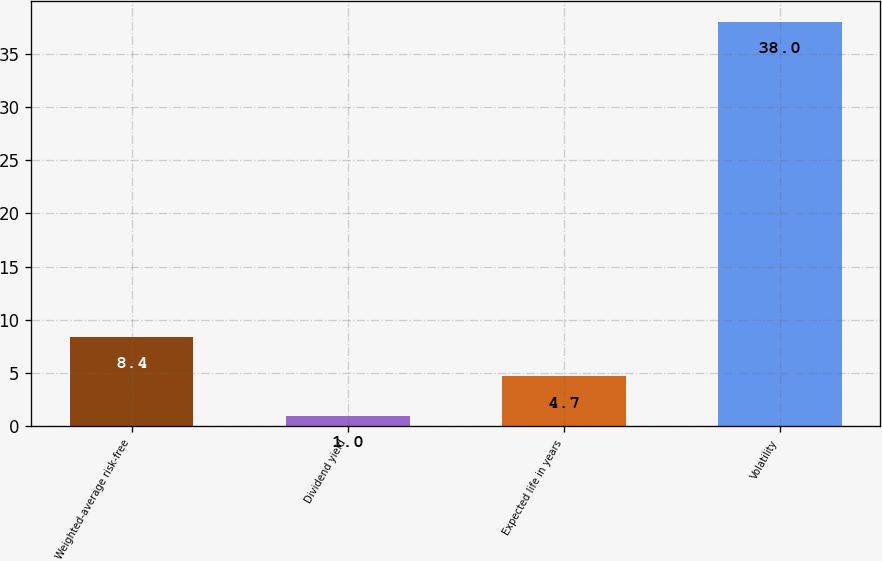<chart> <loc_0><loc_0><loc_500><loc_500><bar_chart><fcel>Weighted-average risk-free<fcel>Dividend yield<fcel>Expected life in years<fcel>Volatility<nl><fcel>8.4<fcel>1<fcel>4.7<fcel>38<nl></chart> 